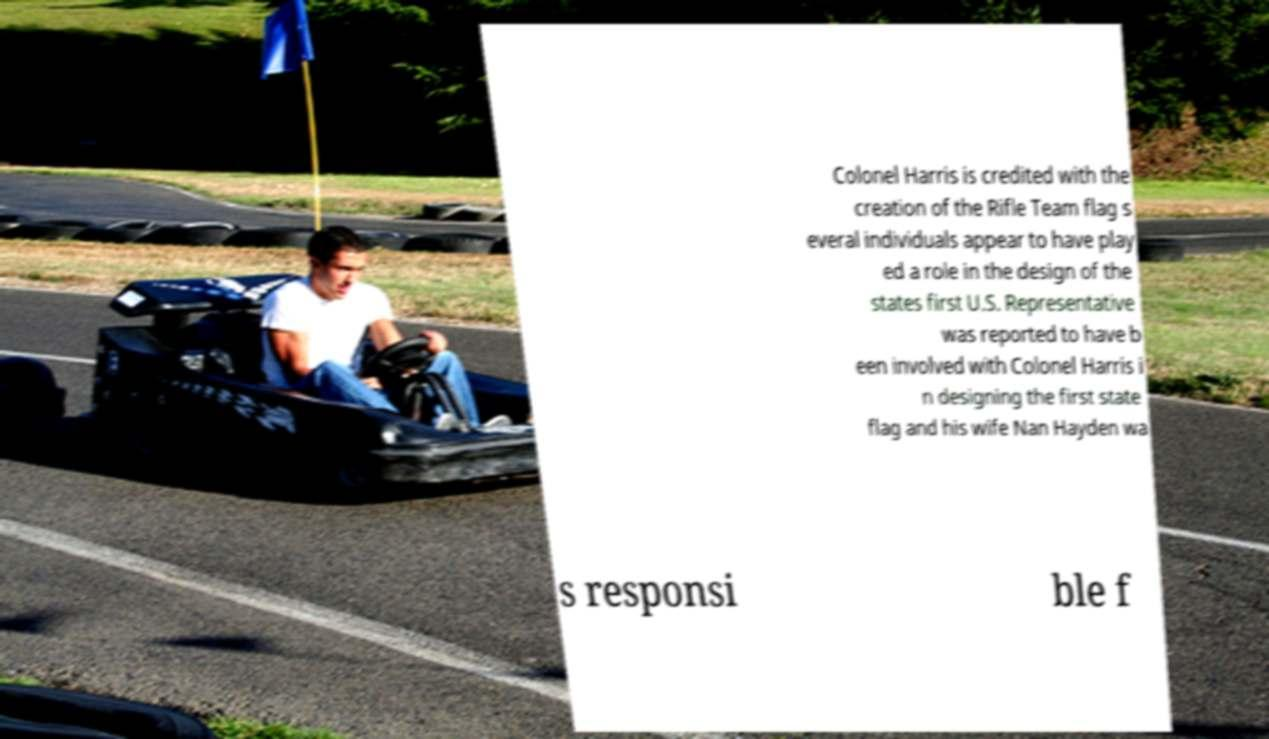There's text embedded in this image that I need extracted. Can you transcribe it verbatim? Colonel Harris is credited with the creation of the Rifle Team flag s everal individuals appear to have play ed a role in the design of the states first U.S. Representative was reported to have b een involved with Colonel Harris i n designing the first state flag and his wife Nan Hayden wa s responsi ble f 